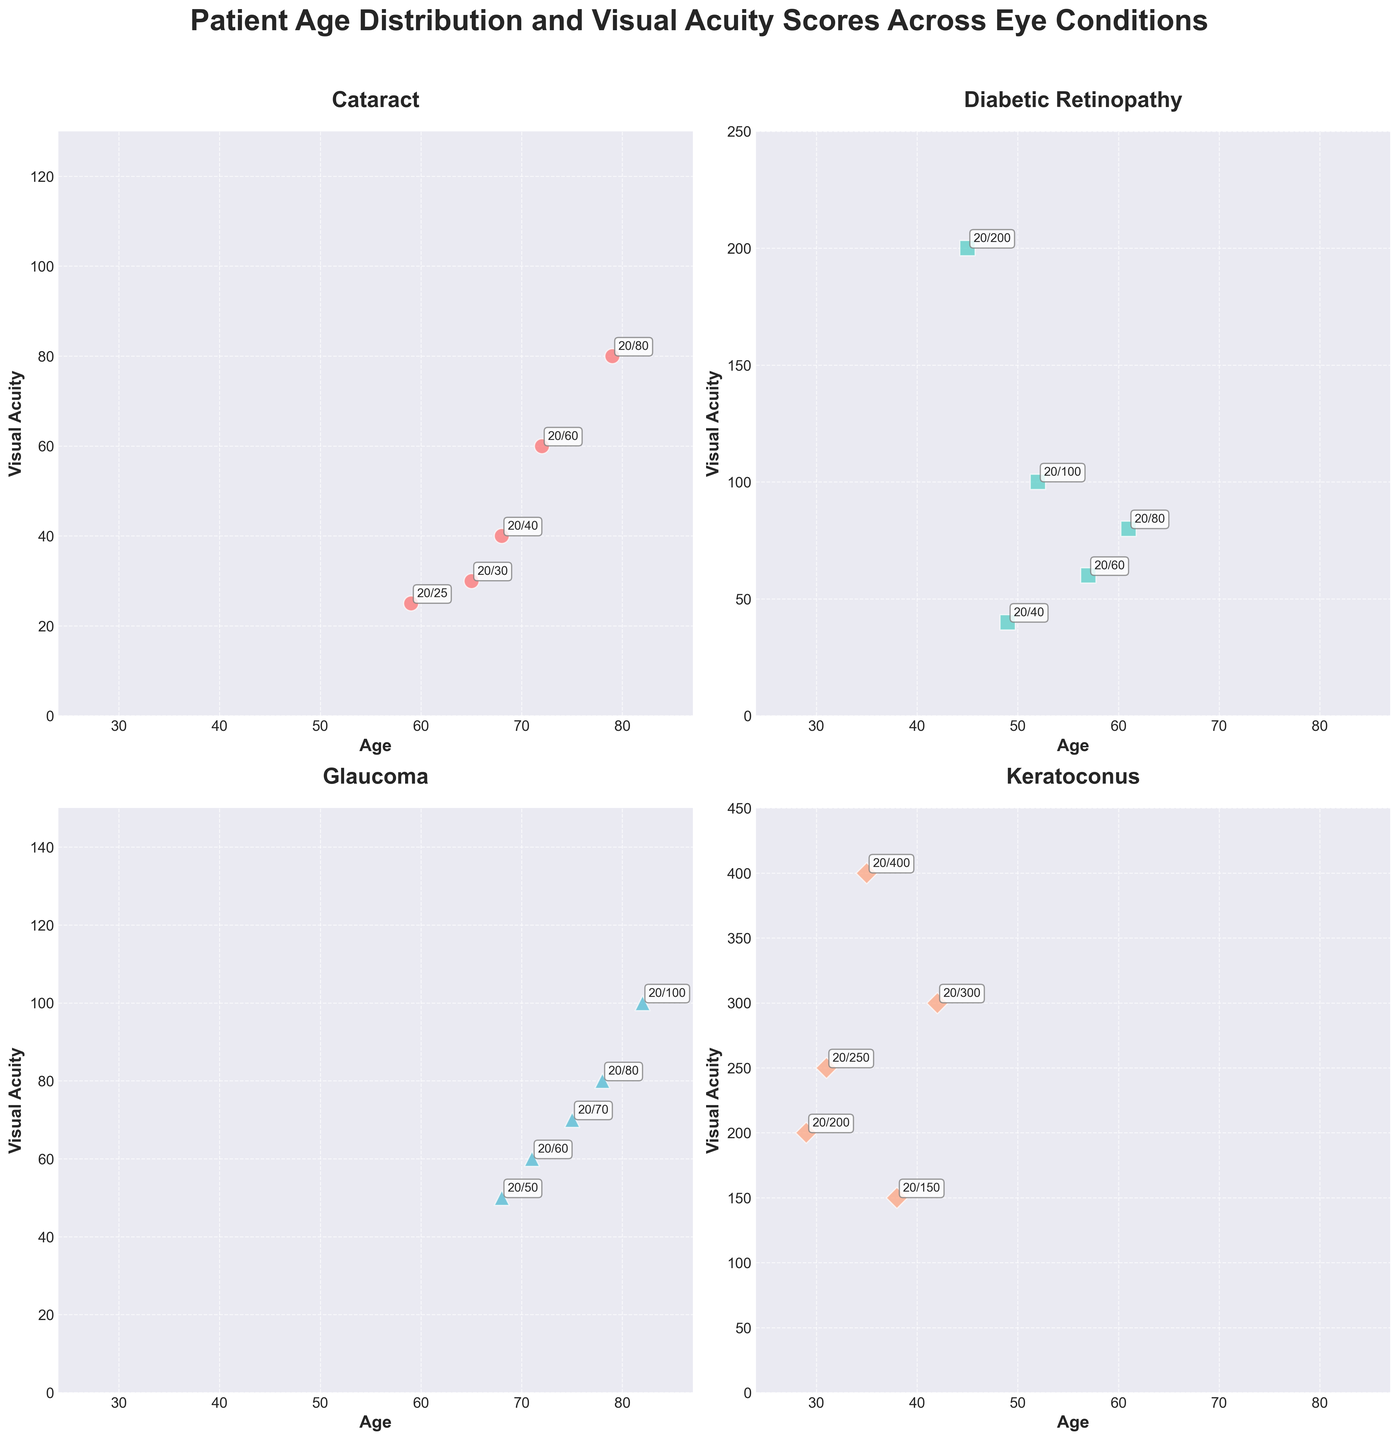What are the titles of the four subplots? The titles of the four subplots are labeled by the eye conditions displayed. The subplots are titled "Cataract", "Diabetic Retinopathy", "Glaucoma", and "Keratoconus".
Answer: Cataract, Diabetic Retinopathy, Glaucoma, Keratoconus What is the age range of the patients across all conditions? The x-axis for each subplot shows the age range. The minimum age is 29 years (in Keratoconus), and the maximum age is 82 years (in Glaucoma).
Answer: 29-82 years Which eye condition has the worst visual acuity score? By looking at all the y-axes in the subplots, Keratoconus shows the worst visual acuity score, which is 20/400.
Answer: Keratoconus What is the most common visual acuity score for patients with Cataract? By observing the scatter plot for Cataract, the visual acuity scores are labeled. The most frequently appearing score is 20/60, appearing twice.
Answer: 20/60 Are there any patients in the age range of 60-70 with Diabetic Retinopathy? By examining the scatter plot for Diabetic Retinopathy, the ages of the patients are labeled. There are three patients aged 61, 57, and 49, thus including the age range 60-70.
Answer: Yes Which eye condition has the highest number of data points? Counting the data points (markers) in each subplot, Diabetic Retinopathy has 5 data points, the most among all conditions.
Answer: Diabetic Retinopathy On average, do patients with Glaucoma or Cataract have higher visual acuity scores? For Glaucoma, convert visual acuity scores to numerical values: 20/70 = 70, 20/50 = 50, 20/100 = 100, 20/60 = 60, 20/80 = 80. Average: (70+50+100+60+80)/5 = 72. For Cataract: 20/40 = 40, 20/60 = 60, 20/30 = 30, 20/80 = 80, 20/25 = 25. Average: (40+60+30+80+25)/5 = 47. Thus, patients with Cataract have higher visual acuity scores on average.
Answer: Cataract Do any conditions have data points with the same age and visual acuity scores? By checking each subplot closely, no condition has multiple patients with the exact same combination of age and visual acuity score.
Answer: No Which condition shows the largest variation in visual acuity among its patients? By observing the range of visual acuity scores on the y-axis for each subplot, Keratoconus shows the largest range from 20/150 to 20/400, indicating the largest variation.
Answer: Keratoconus 